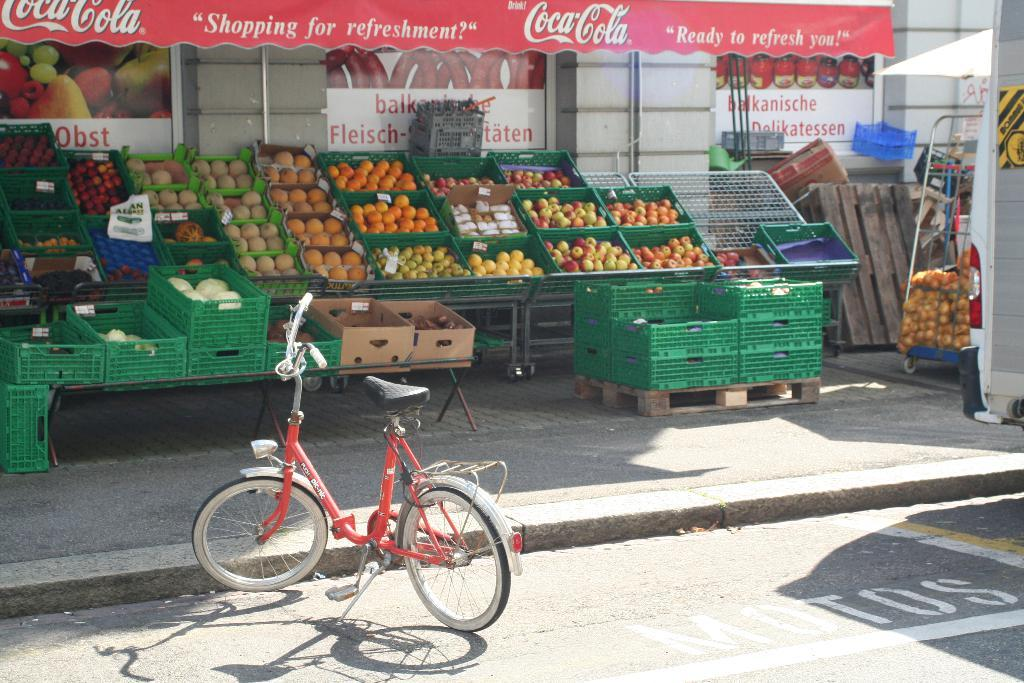<image>
Render a clear and concise summary of the photo. A fruit stand outside a store with an awning saying Coca-Cola. 